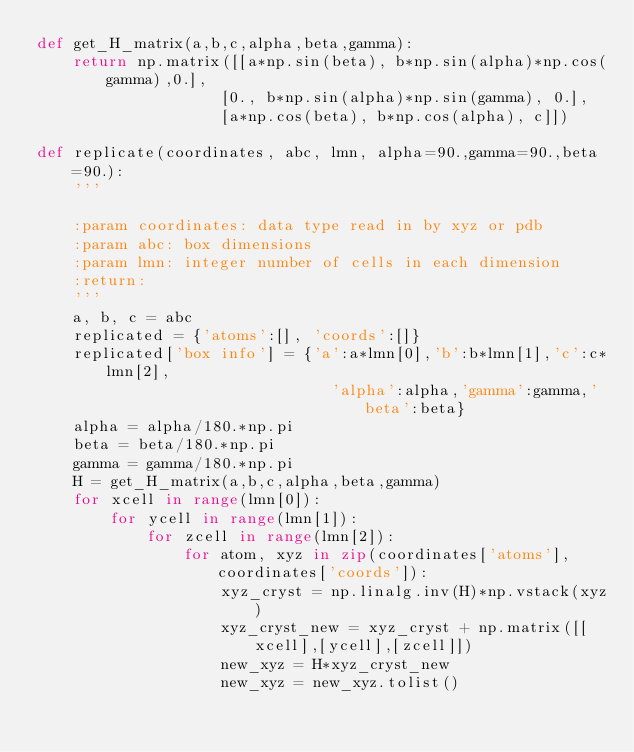<code> <loc_0><loc_0><loc_500><loc_500><_Python_>def get_H_matrix(a,b,c,alpha,beta,gamma):
    return np.matrix([[a*np.sin(beta), b*np.sin(alpha)*np.cos(gamma),0.],
                    [0., b*np.sin(alpha)*np.sin(gamma), 0.],
                    [a*np.cos(beta), b*np.cos(alpha), c]])

def replicate(coordinates, abc, lmn, alpha=90.,gamma=90.,beta=90.):
    '''

    :param coordinates: data type read in by xyz or pdb
    :param abc: box dimensions
    :param lmn: integer number of cells in each dimension
    :return:
    '''
    a, b, c = abc
    replicated = {'atoms':[], 'coords':[]}
    replicated['box info'] = {'a':a*lmn[0],'b':b*lmn[1],'c':c*lmn[2],
                                'alpha':alpha,'gamma':gamma,'beta':beta}
    alpha = alpha/180.*np.pi
    beta = beta/180.*np.pi
    gamma = gamma/180.*np.pi
    H = get_H_matrix(a,b,c,alpha,beta,gamma)
    for xcell in range(lmn[0]):
        for ycell in range(lmn[1]):
            for zcell in range(lmn[2]):
                for atom, xyz in zip(coordinates['atoms'], coordinates['coords']):
                    xyz_cryst = np.linalg.inv(H)*np.vstack(xyz)
                    xyz_cryst_new = xyz_cryst + np.matrix([[xcell],[ycell],[zcell]])
                    new_xyz = H*xyz_cryst_new
                    new_xyz = new_xyz.tolist()</code> 